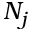Convert formula to latex. <formula><loc_0><loc_0><loc_500><loc_500>N _ { j }</formula> 